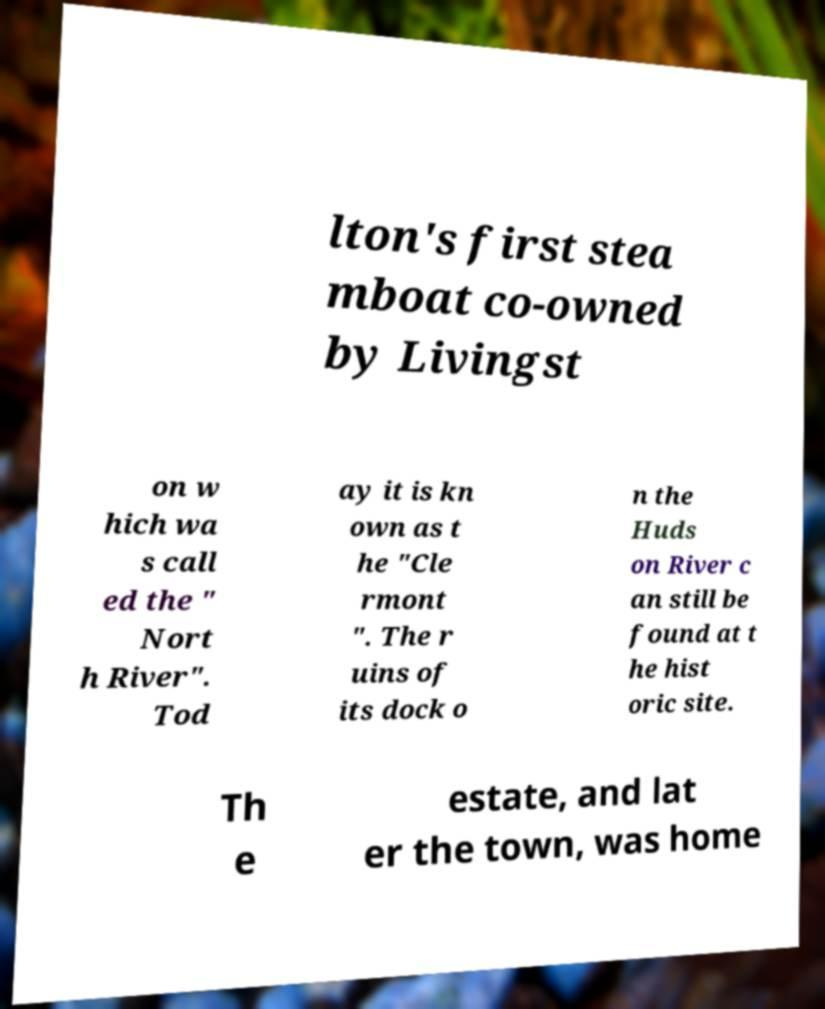For documentation purposes, I need the text within this image transcribed. Could you provide that? lton's first stea mboat co-owned by Livingst on w hich wa s call ed the " Nort h River". Tod ay it is kn own as t he "Cle rmont ". The r uins of its dock o n the Huds on River c an still be found at t he hist oric site. Th e estate, and lat er the town, was home 